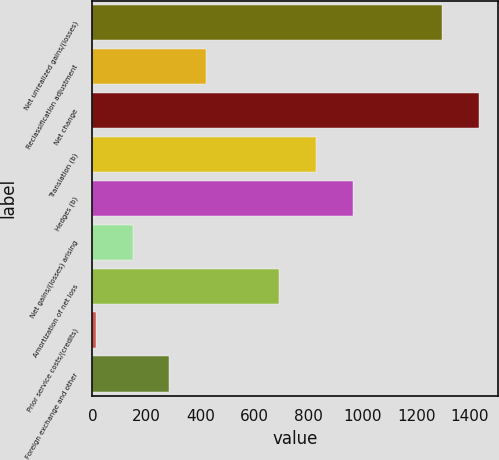Convert chart. <chart><loc_0><loc_0><loc_500><loc_500><bar_chart><fcel>Net unrealized gains/(losses)<fcel>Reclassification adjustment<fcel>Net change<fcel>Translation (b)<fcel>Hedges (b)<fcel>Net gains/(losses) arising<fcel>Amortization of net loss<fcel>Prior service costs/(credits)<fcel>Foreign exchange and other<nl><fcel>1297<fcel>421.7<fcel>1432.9<fcel>829.4<fcel>965.3<fcel>149.9<fcel>693.5<fcel>14<fcel>285.8<nl></chart> 